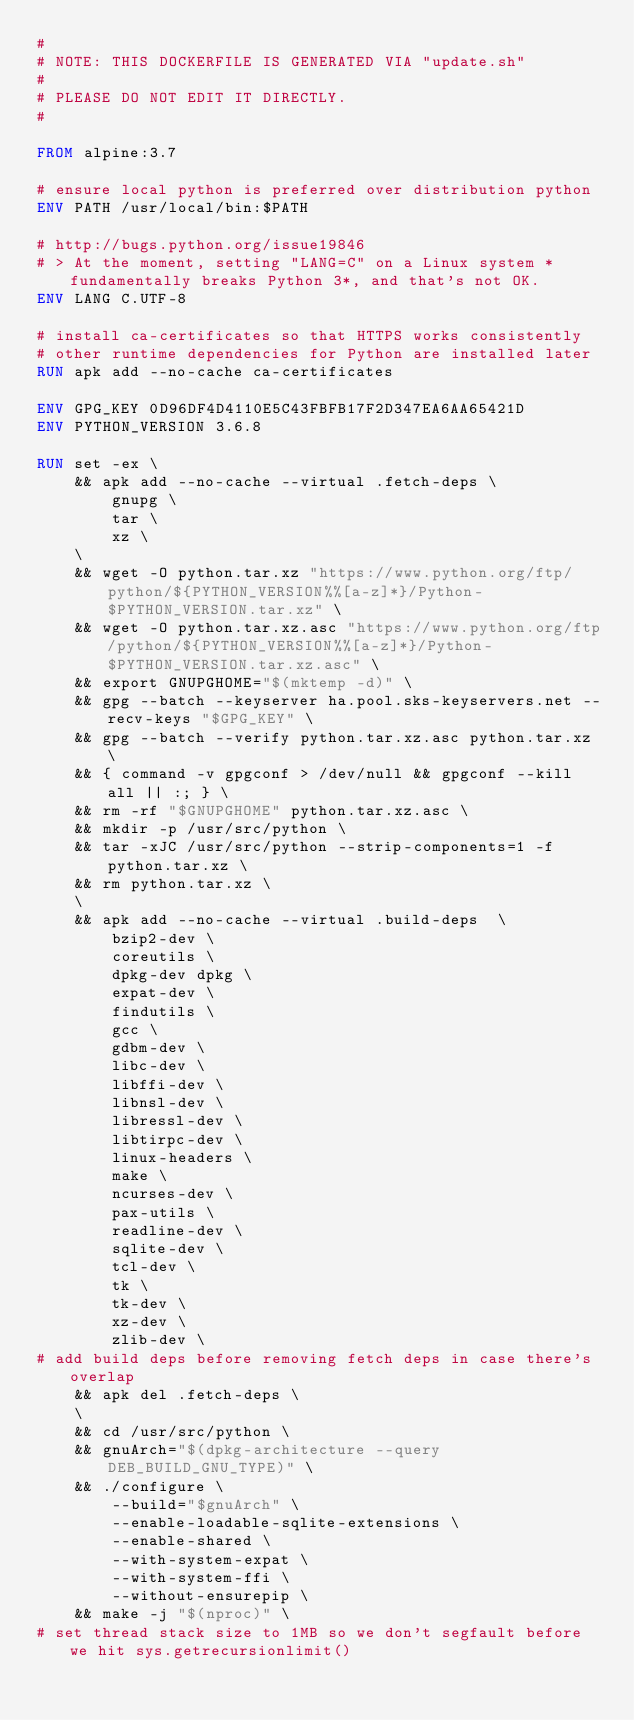<code> <loc_0><loc_0><loc_500><loc_500><_Dockerfile_>#
# NOTE: THIS DOCKERFILE IS GENERATED VIA "update.sh"
#
# PLEASE DO NOT EDIT IT DIRECTLY.
#

FROM alpine:3.7

# ensure local python is preferred over distribution python
ENV PATH /usr/local/bin:$PATH

# http://bugs.python.org/issue19846
# > At the moment, setting "LANG=C" on a Linux system *fundamentally breaks Python 3*, and that's not OK.
ENV LANG C.UTF-8

# install ca-certificates so that HTTPS works consistently
# other runtime dependencies for Python are installed later
RUN apk add --no-cache ca-certificates

ENV GPG_KEY 0D96DF4D4110E5C43FBFB17F2D347EA6AA65421D
ENV PYTHON_VERSION 3.6.8

RUN set -ex \
	&& apk add --no-cache --virtual .fetch-deps \
		gnupg \
		tar \
		xz \
	\
	&& wget -O python.tar.xz "https://www.python.org/ftp/python/${PYTHON_VERSION%%[a-z]*}/Python-$PYTHON_VERSION.tar.xz" \
	&& wget -O python.tar.xz.asc "https://www.python.org/ftp/python/${PYTHON_VERSION%%[a-z]*}/Python-$PYTHON_VERSION.tar.xz.asc" \
	&& export GNUPGHOME="$(mktemp -d)" \
	&& gpg --batch --keyserver ha.pool.sks-keyservers.net --recv-keys "$GPG_KEY" \
	&& gpg --batch --verify python.tar.xz.asc python.tar.xz \
	&& { command -v gpgconf > /dev/null && gpgconf --kill all || :; } \
	&& rm -rf "$GNUPGHOME" python.tar.xz.asc \
	&& mkdir -p /usr/src/python \
	&& tar -xJC /usr/src/python --strip-components=1 -f python.tar.xz \
	&& rm python.tar.xz \
	\
	&& apk add --no-cache --virtual .build-deps  \
		bzip2-dev \
		coreutils \
		dpkg-dev dpkg \
		expat-dev \
		findutils \
		gcc \
		gdbm-dev \
		libc-dev \
		libffi-dev \
		libnsl-dev \
		libressl-dev \
		libtirpc-dev \
		linux-headers \
		make \
		ncurses-dev \
		pax-utils \
		readline-dev \
		sqlite-dev \
		tcl-dev \
		tk \
		tk-dev \
		xz-dev \
		zlib-dev \
# add build deps before removing fetch deps in case there's overlap
	&& apk del .fetch-deps \
	\
	&& cd /usr/src/python \
	&& gnuArch="$(dpkg-architecture --query DEB_BUILD_GNU_TYPE)" \
	&& ./configure \
		--build="$gnuArch" \
		--enable-loadable-sqlite-extensions \
		--enable-shared \
		--with-system-expat \
		--with-system-ffi \
		--without-ensurepip \
	&& make -j "$(nproc)" \
# set thread stack size to 1MB so we don't segfault before we hit sys.getrecursionlimit()</code> 